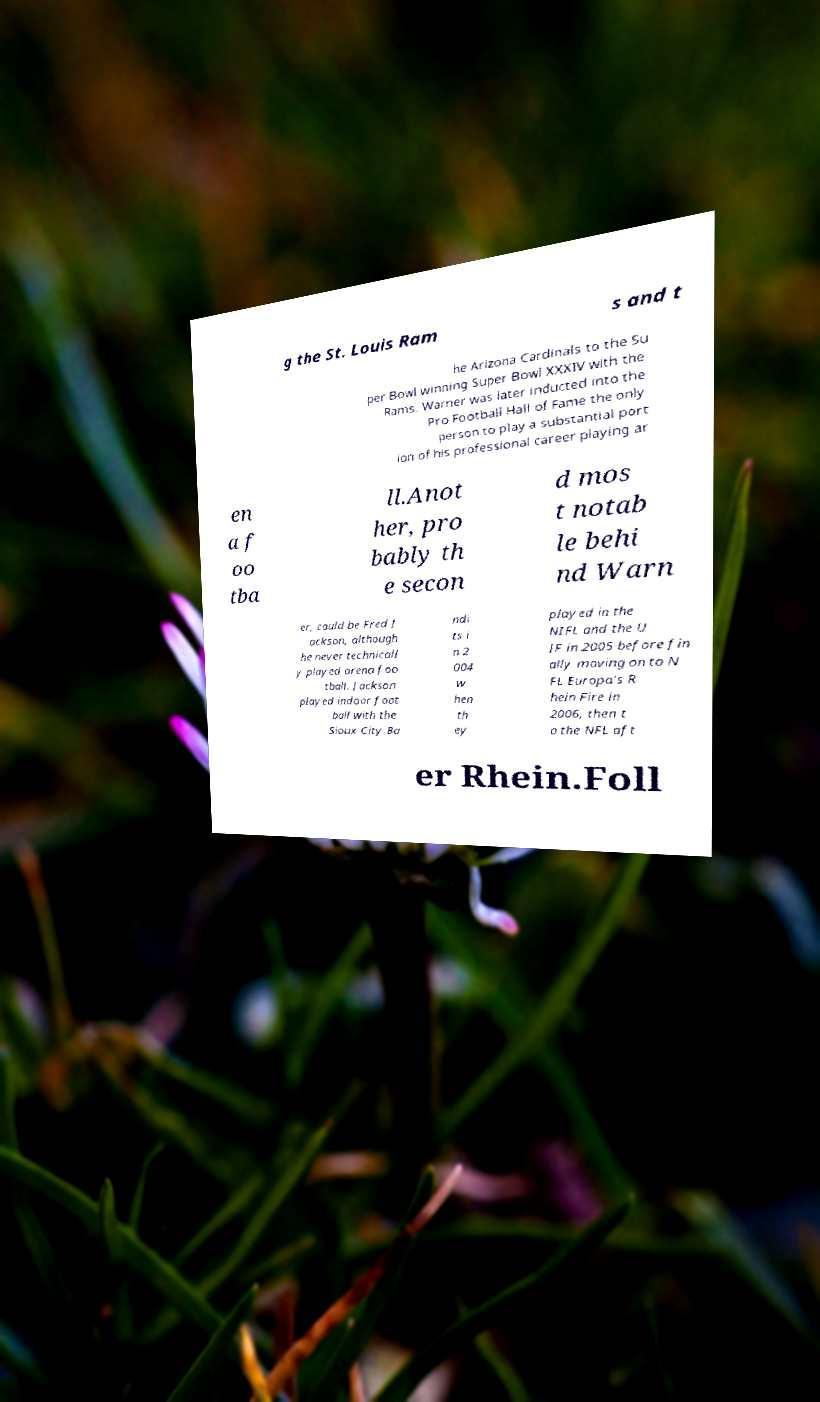For documentation purposes, I need the text within this image transcribed. Could you provide that? g the St. Louis Ram s and t he Arizona Cardinals to the Su per Bowl winning Super Bowl XXXIV with the Rams. Warner was later inducted into the Pro Football Hall of Fame the only person to play a substantial port ion of his professional career playing ar en a f oo tba ll.Anot her, pro bably th e secon d mos t notab le behi nd Warn er, could be Fred J ackson, although he never technicall y played arena foo tball. Jackson played indoor foot ball with the Sioux City Ba ndi ts i n 2 004 w hen th ey played in the NIFL and the U IF in 2005 before fin ally moving on to N FL Europa's R hein Fire in 2006, then t o the NFL aft er Rhein.Foll 